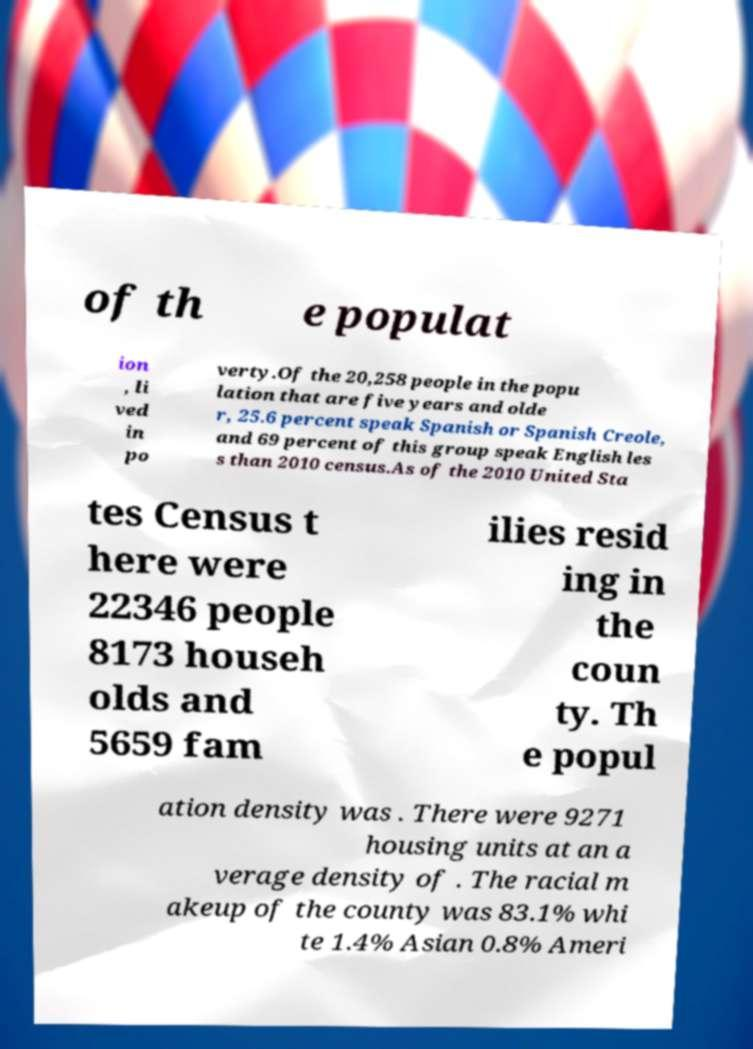What messages or text are displayed in this image? I need them in a readable, typed format. of th e populat ion , li ved in po verty.Of the 20,258 people in the popu lation that are five years and olde r, 25.6 percent speak Spanish or Spanish Creole, and 69 percent of this group speak English les s than 2010 census.As of the 2010 United Sta tes Census t here were 22346 people 8173 househ olds and 5659 fam ilies resid ing in the coun ty. Th e popul ation density was . There were 9271 housing units at an a verage density of . The racial m akeup of the county was 83.1% whi te 1.4% Asian 0.8% Ameri 